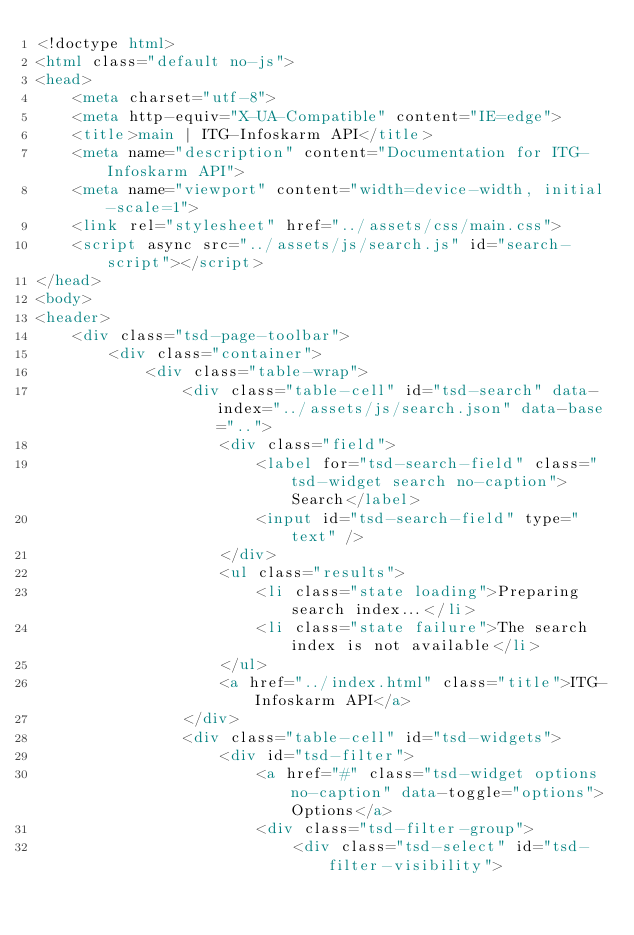<code> <loc_0><loc_0><loc_500><loc_500><_HTML_><!doctype html>
<html class="default no-js">
<head>
	<meta charset="utf-8">
	<meta http-equiv="X-UA-Compatible" content="IE=edge">
	<title>main | ITG-Infoskarm API</title>
	<meta name="description" content="Documentation for ITG-Infoskarm API">
	<meta name="viewport" content="width=device-width, initial-scale=1">
	<link rel="stylesheet" href="../assets/css/main.css">
	<script async src="../assets/js/search.js" id="search-script"></script>
</head>
<body>
<header>
	<div class="tsd-page-toolbar">
		<div class="container">
			<div class="table-wrap">
				<div class="table-cell" id="tsd-search" data-index="../assets/js/search.json" data-base="..">
					<div class="field">
						<label for="tsd-search-field" class="tsd-widget search no-caption">Search</label>
						<input id="tsd-search-field" type="text" />
					</div>
					<ul class="results">
						<li class="state loading">Preparing search index...</li>
						<li class="state failure">The search index is not available</li>
					</ul>
					<a href="../index.html" class="title">ITG-Infoskarm API</a>
				</div>
				<div class="table-cell" id="tsd-widgets">
					<div id="tsd-filter">
						<a href="#" class="tsd-widget options no-caption" data-toggle="options">Options</a>
						<div class="tsd-filter-group">
							<div class="tsd-select" id="tsd-filter-visibility"></code> 